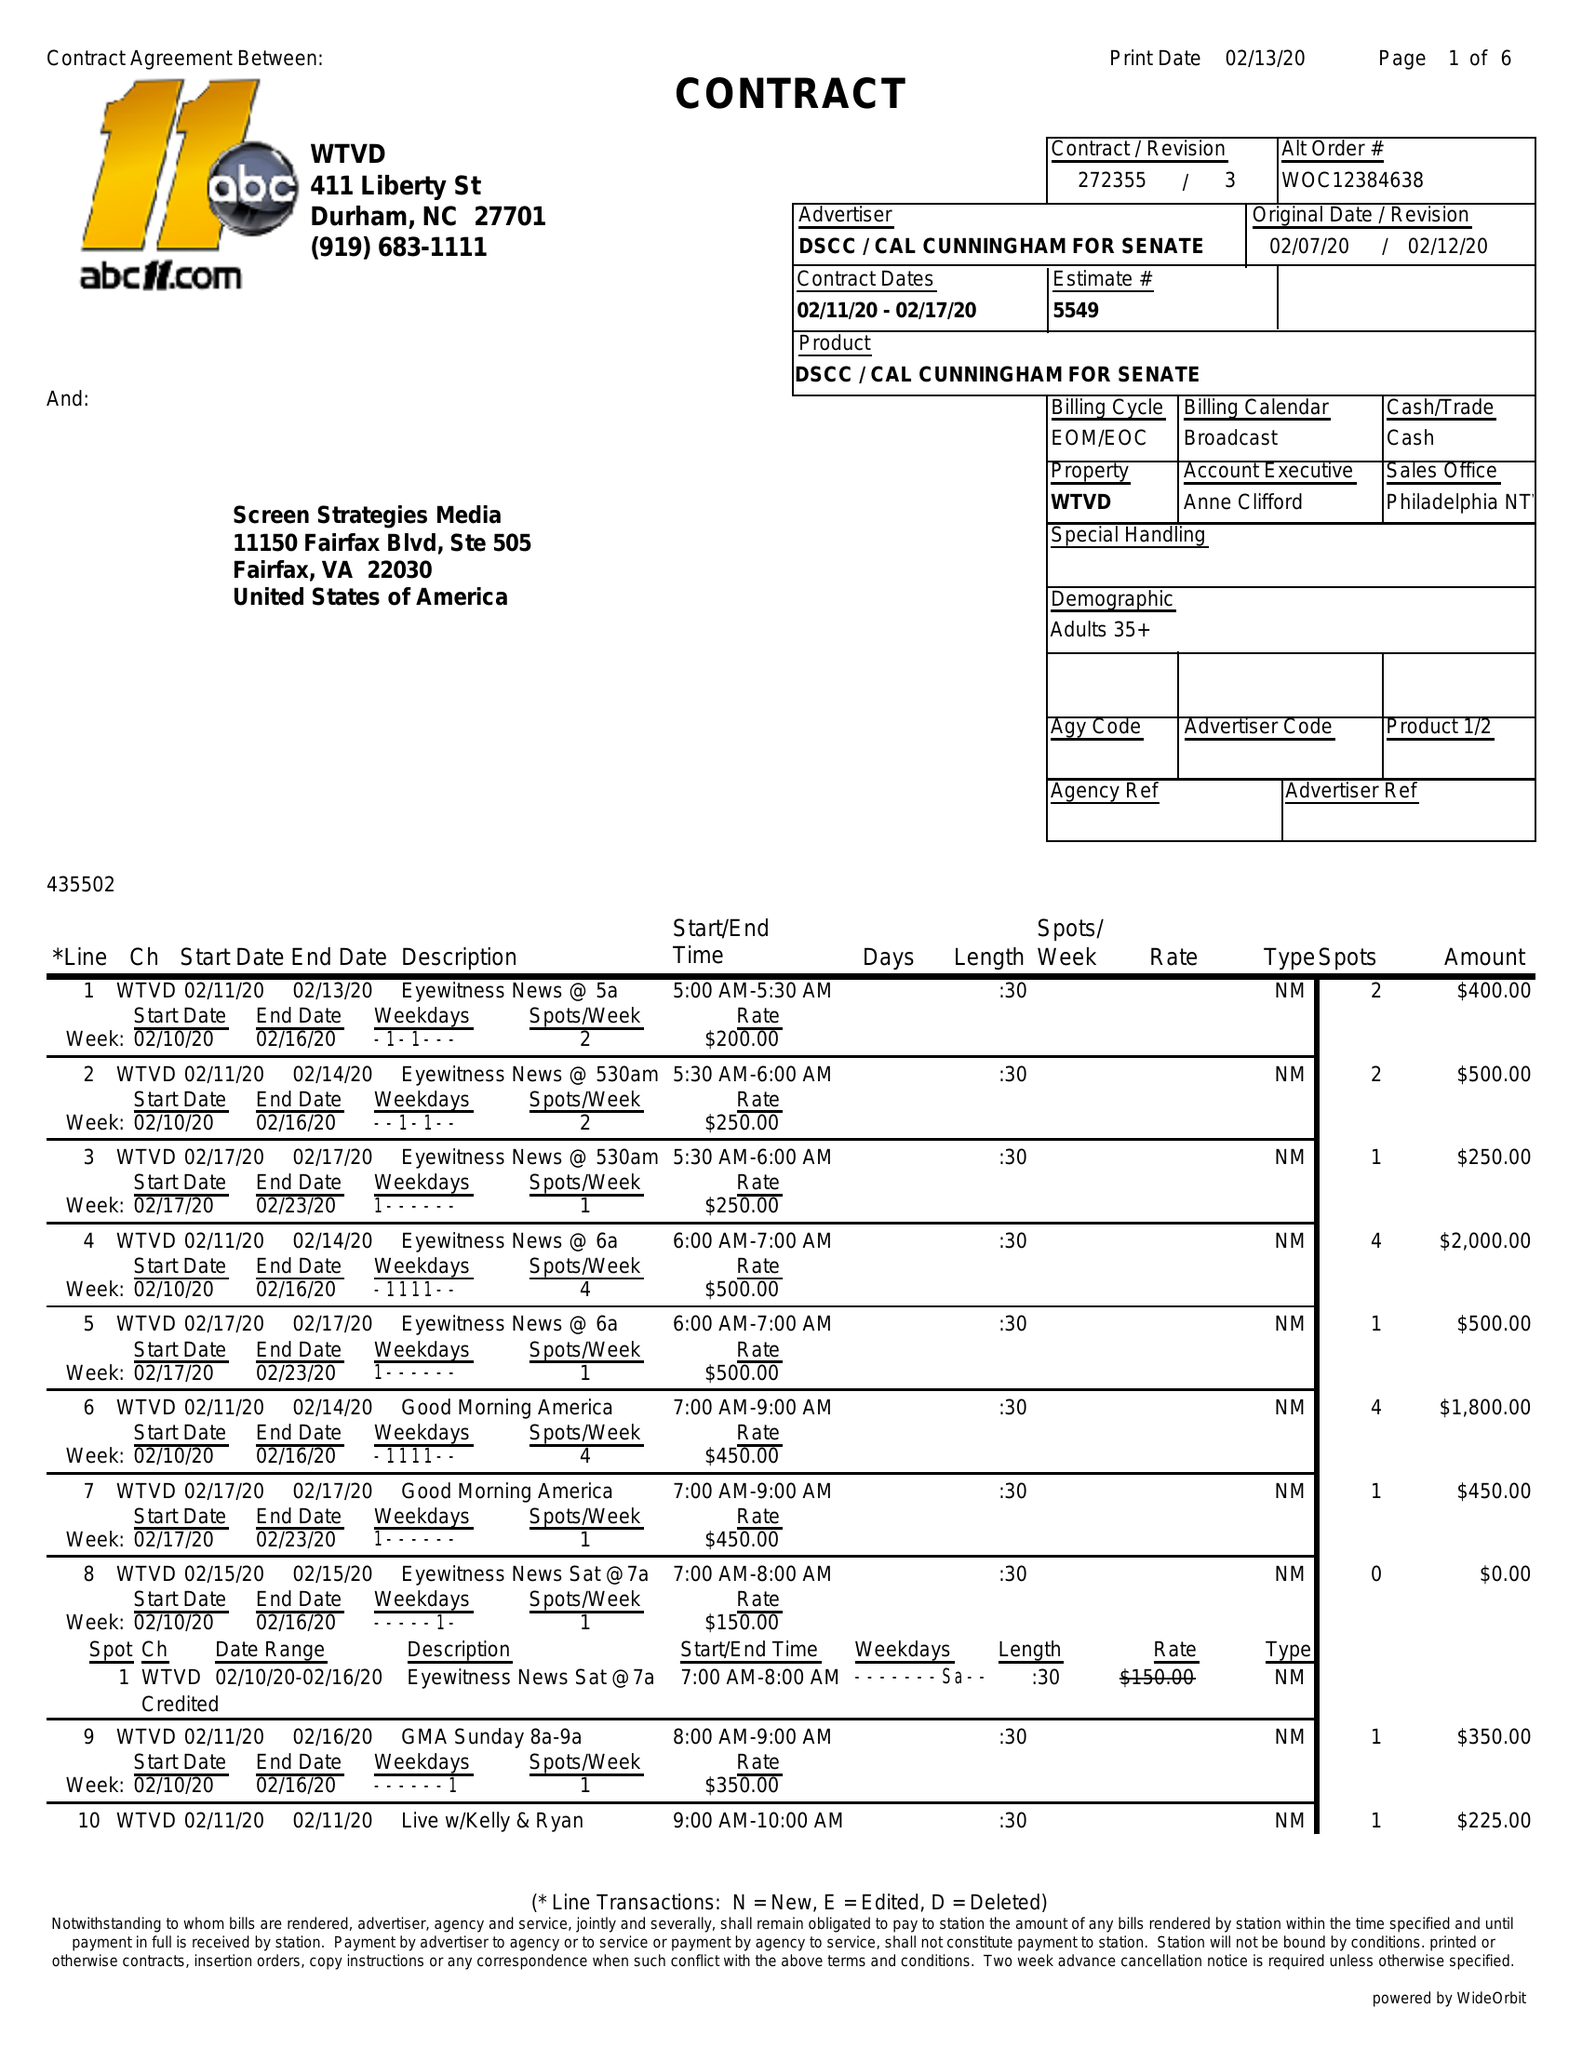What is the value for the gross_amount?
Answer the question using a single word or phrase. 39500.00 